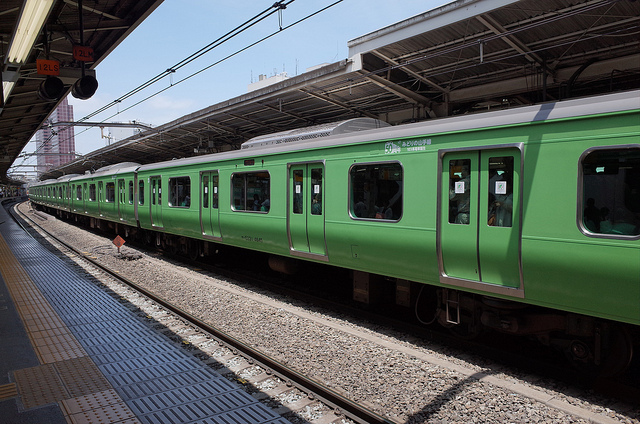Identify and read out the text in this image. 50 